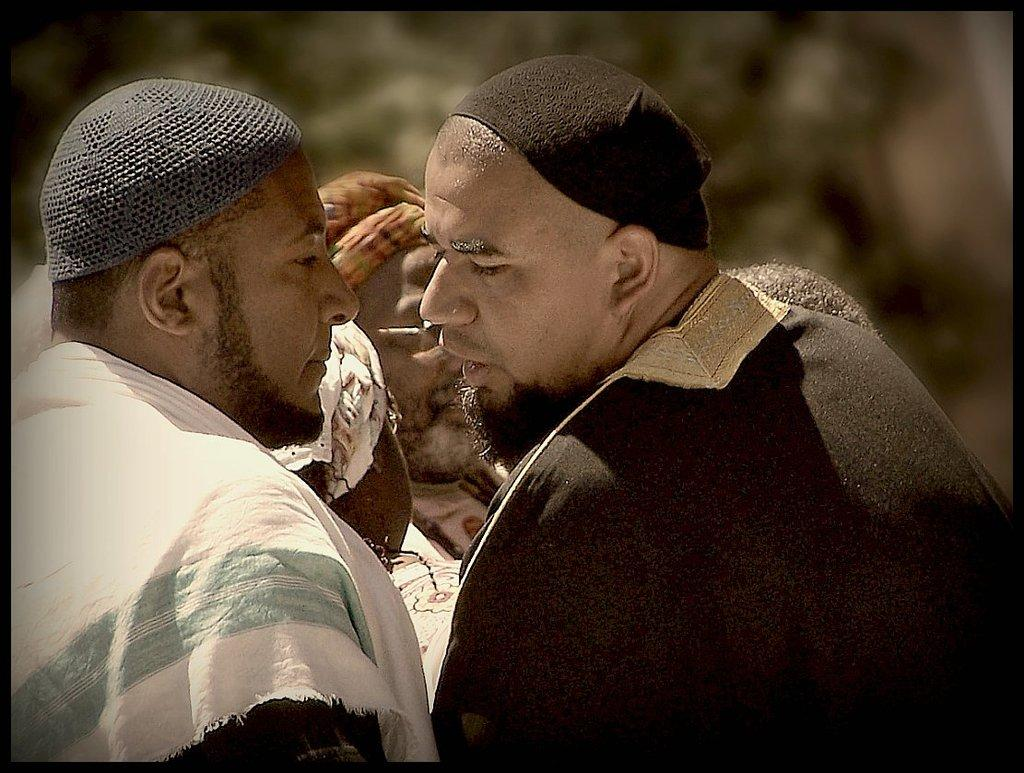What type of people are in the image? There are Arab men in the image. What are the Arab men doing in the image? The Arab men are standing. Can you describe the background of the image? The background of the image is blurry. What type of soda is being consumed by the Arab men in the image? There is no soda present in the image, and therefore no such consumption can be observed. What kind of toy is being played with by the Arab men in the image? There is no toy present in the image, and therefore no such play can be observed. --- 